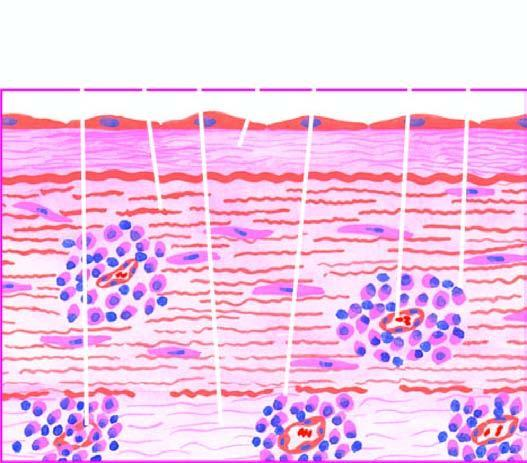s there endarteritis and periarteritis of the vasa vasorum in the media and adventitia?
Answer the question using a single word or phrase. Yes 